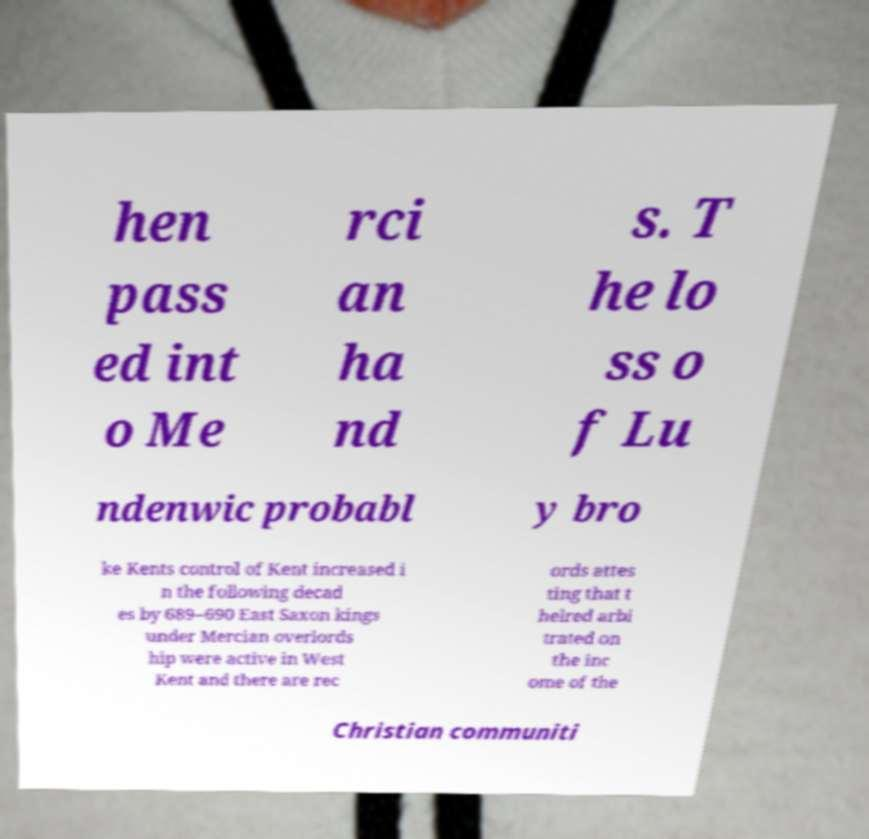There's text embedded in this image that I need extracted. Can you transcribe it verbatim? hen pass ed int o Me rci an ha nd s. T he lo ss o f Lu ndenwic probabl y bro ke Kents control of Kent increased i n the following decad es by 689–690 East Saxon kings under Mercian overlords hip were active in West Kent and there are rec ords attes ting that t helred arbi trated on the inc ome of the Christian communiti 